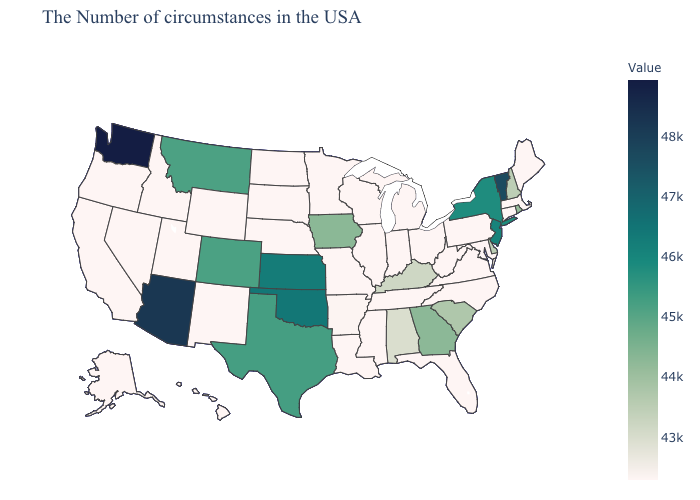Does Rhode Island have the lowest value in the USA?
Be succinct. No. Does Washington have the highest value in the West?
Concise answer only. Yes. Does Arkansas have a higher value than Kansas?
Give a very brief answer. No. Among the states that border Mississippi , which have the highest value?
Be succinct. Alabama. Does New York have the lowest value in the USA?
Be succinct. No. 